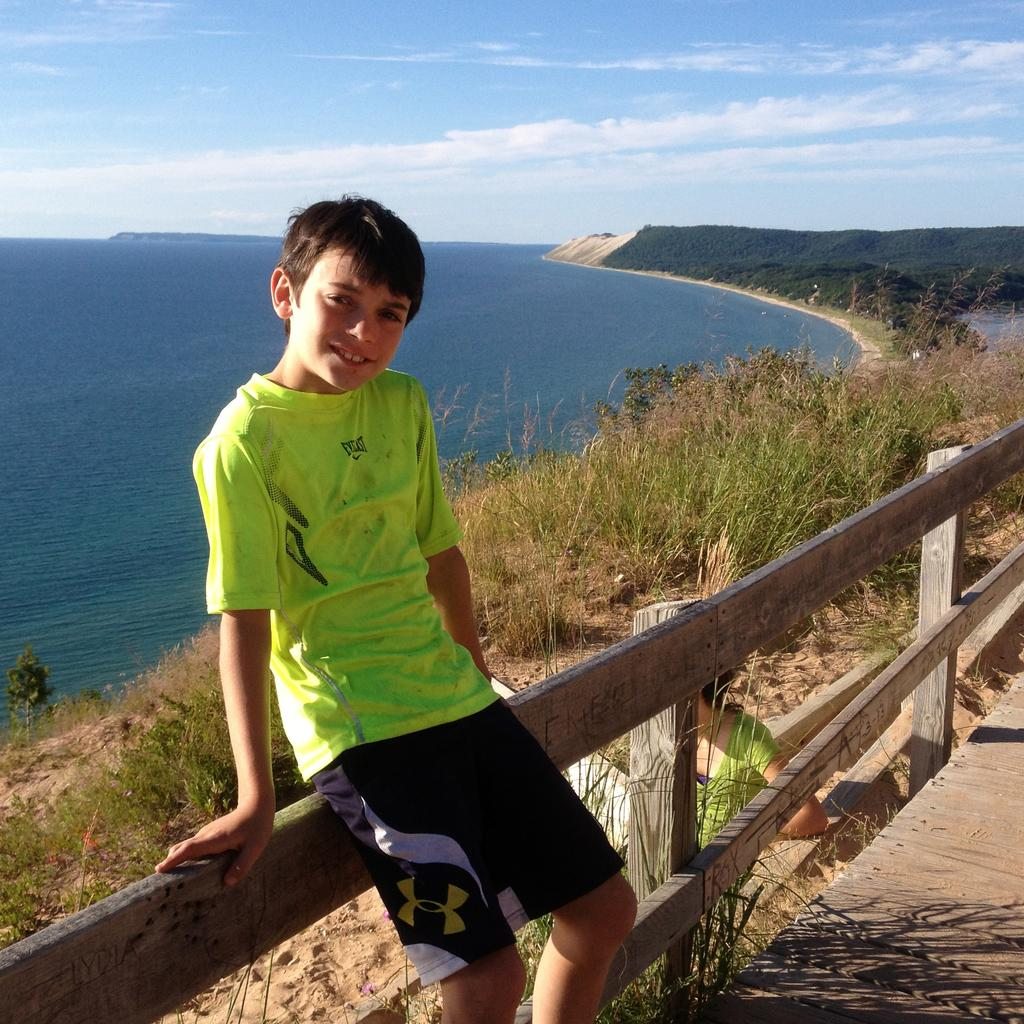<image>
Write a terse but informative summary of the picture. A young boy in a yellow Everlast shirt and black Under Armour shorts poses for a photo in front of the coastline. 